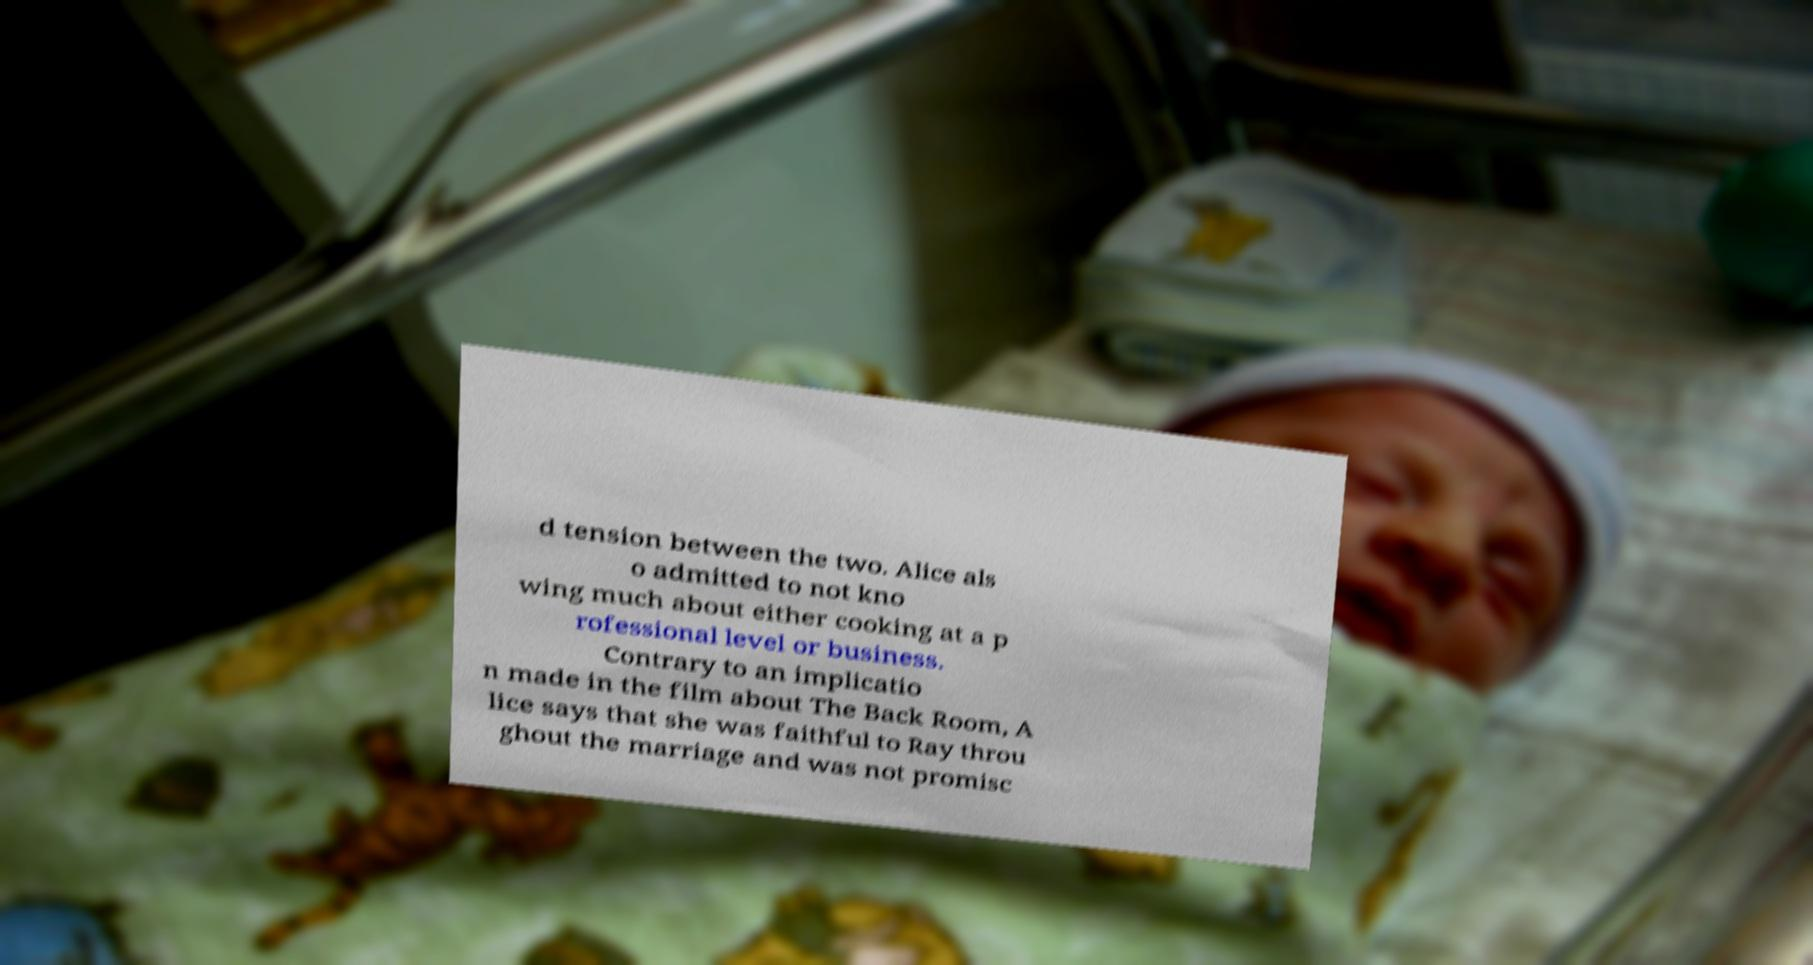Please identify and transcribe the text found in this image. d tension between the two. Alice als o admitted to not kno wing much about either cooking at a p rofessional level or business. Contrary to an implicatio n made in the film about The Back Room, A lice says that she was faithful to Ray throu ghout the marriage and was not promisc 